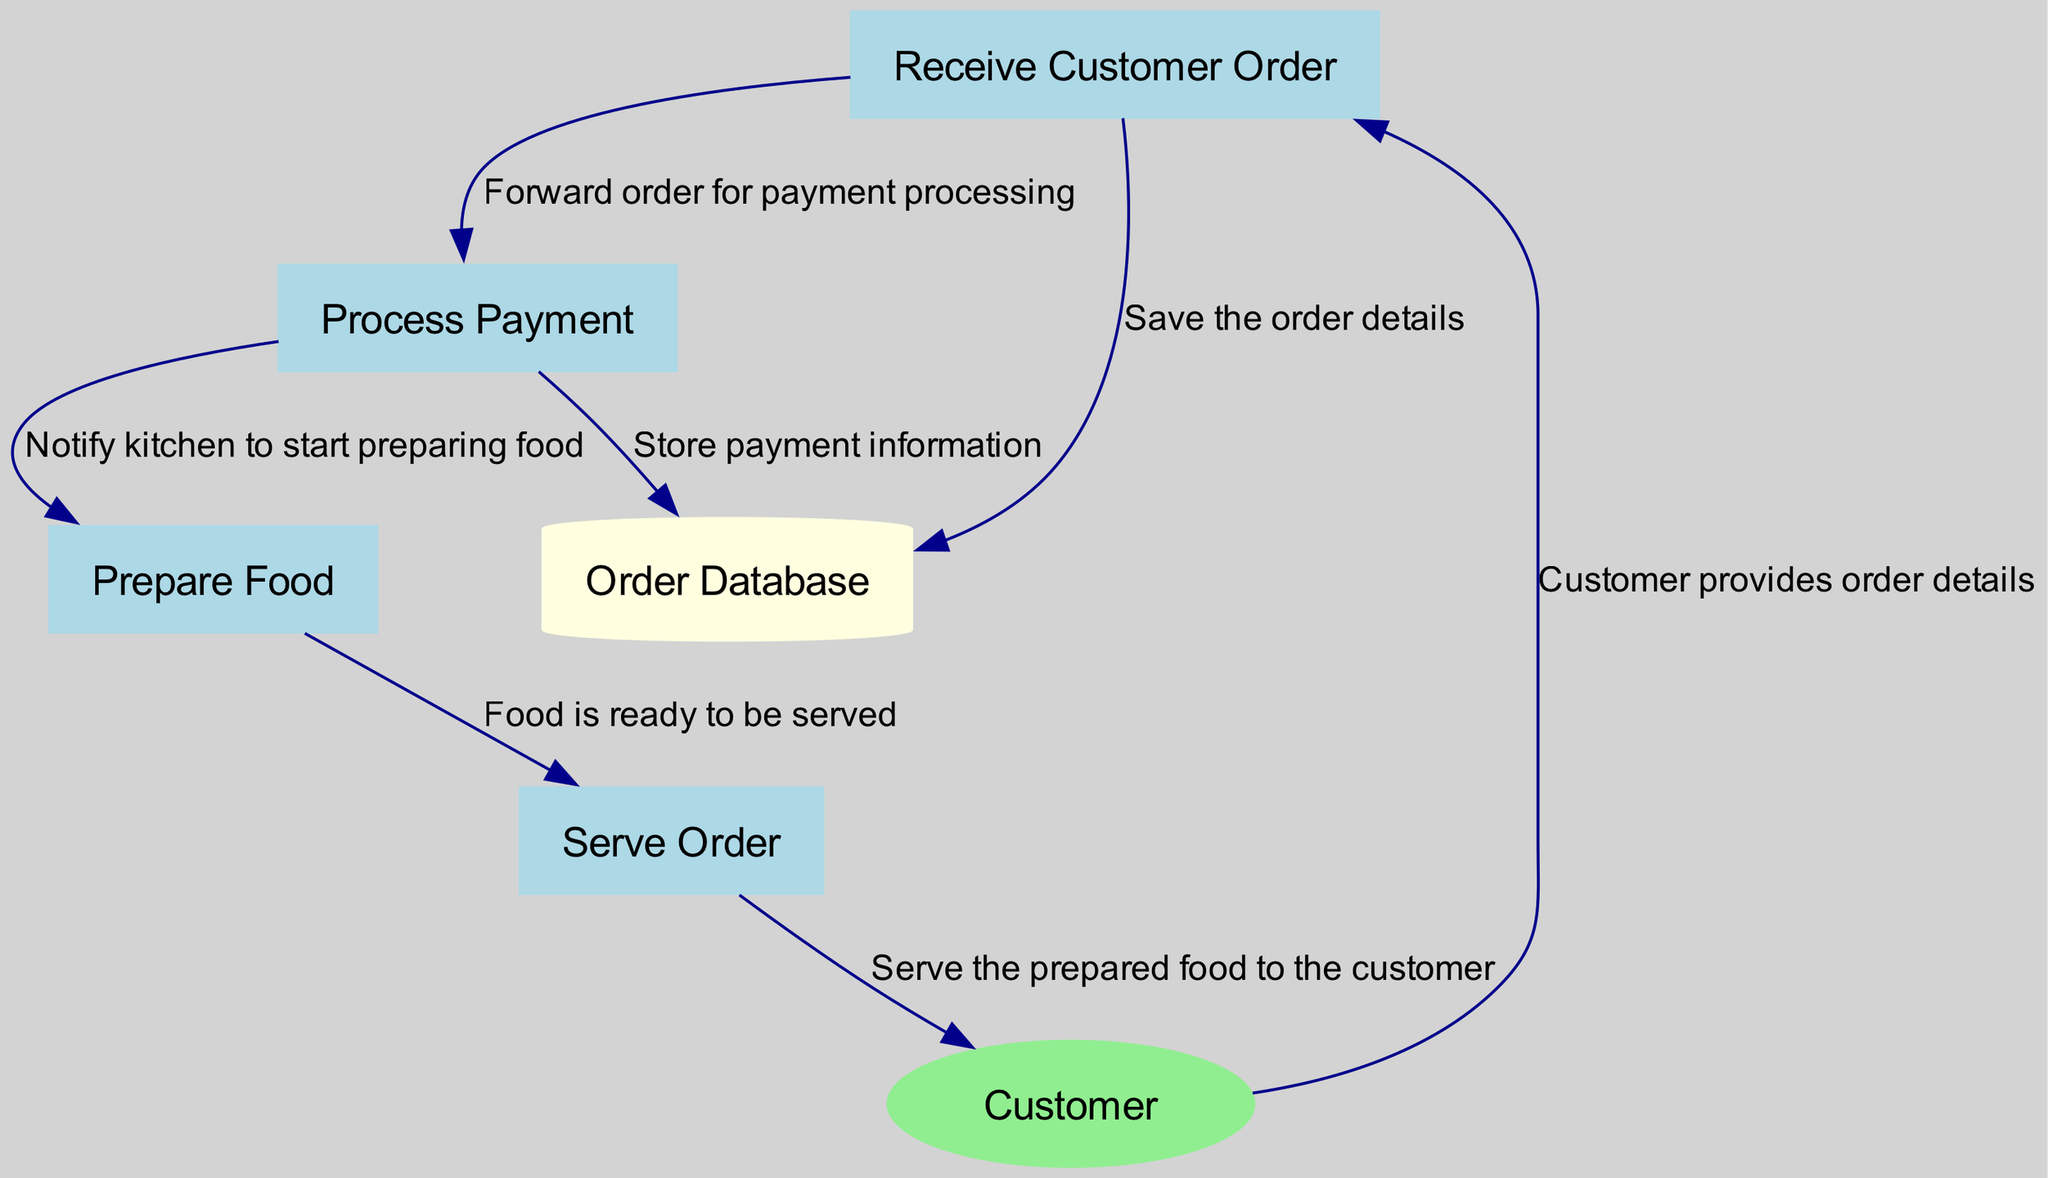What is the first process in the workflow? The first process is identified as "Receive Customer Order," which is the starting point where the order details are accepted from the customer.
Answer: Receive Customer Order How many processes are there in total? The diagram lists a total of four processes: Receive Customer Order, Process Payment, Prepare Food, and Serve Order.
Answer: 4 What type of entity is the Customer? The Customer is categorized as an external entity, which means they interact with the restaurant's order processing but are not part of the internal processes.
Answer: External Entity What information is stored in the Order Database? The Order Database stores customer orders and payment details gathered throughout the order processing workflow.
Answer: Customer orders and payment details Which process is responsible for notifying the kitchen? The process "Process Payment" sends a notification to "Prepare Food" to start cooking the food once payment is initiated.
Answer: Process Payment How many data flows are present in the diagram? By analyzing the connections between the nodes, it is determined that there are seven distinct data flows in the diagram.
Answer: 7 What does the arrow from "Prepare Food" to "Serve Order" represent? The arrow indicates that once the food is prepared, it is ready to be served, establishing a direct movement of information regarding food readiness.
Answer: Food is ready to be served What action follows after "Process Payment"? After processing the payment, the next action taken is to notify the kitchen to start preparing food, linking payment processing to food preparation.
Answer: Notify kitchen to start preparing food Who provides the order details? The Customer provides the order details, initiating the entire flow of the order processing workflow.
Answer: Customer 